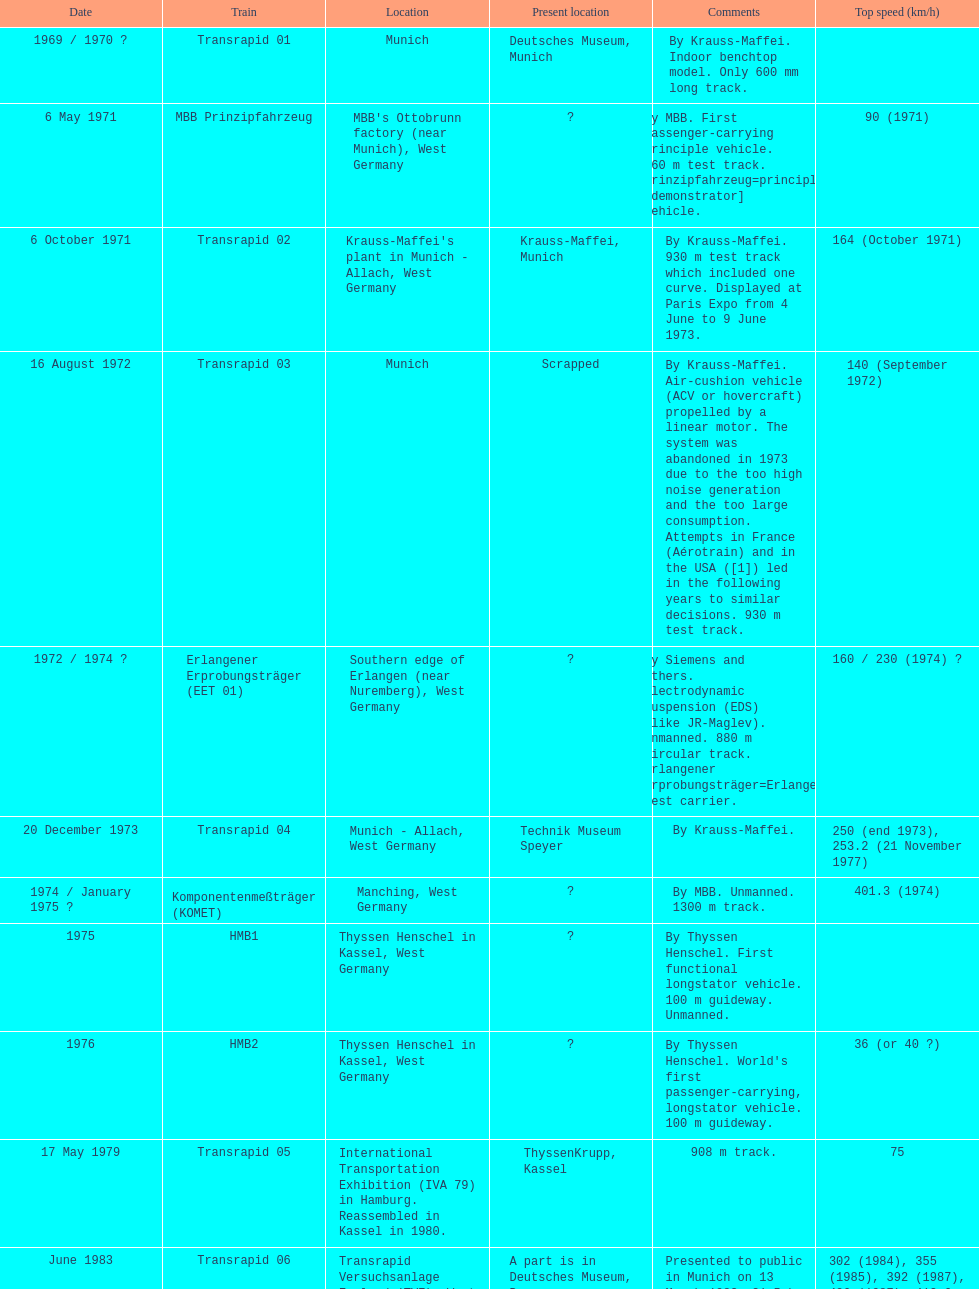How many trains can achieve speeds greater than 450 km/h, excluding the transrapid 07? 1. 